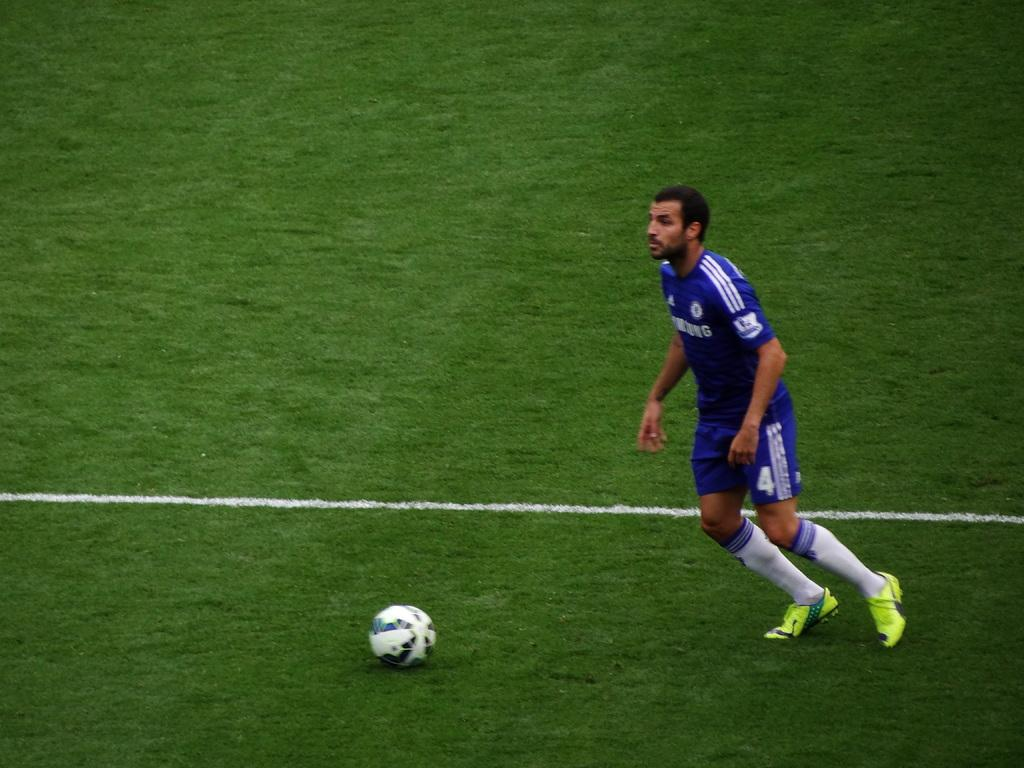<image>
Offer a succinct explanation of the picture presented. The player has a blue jersey sponsored by Samsung 